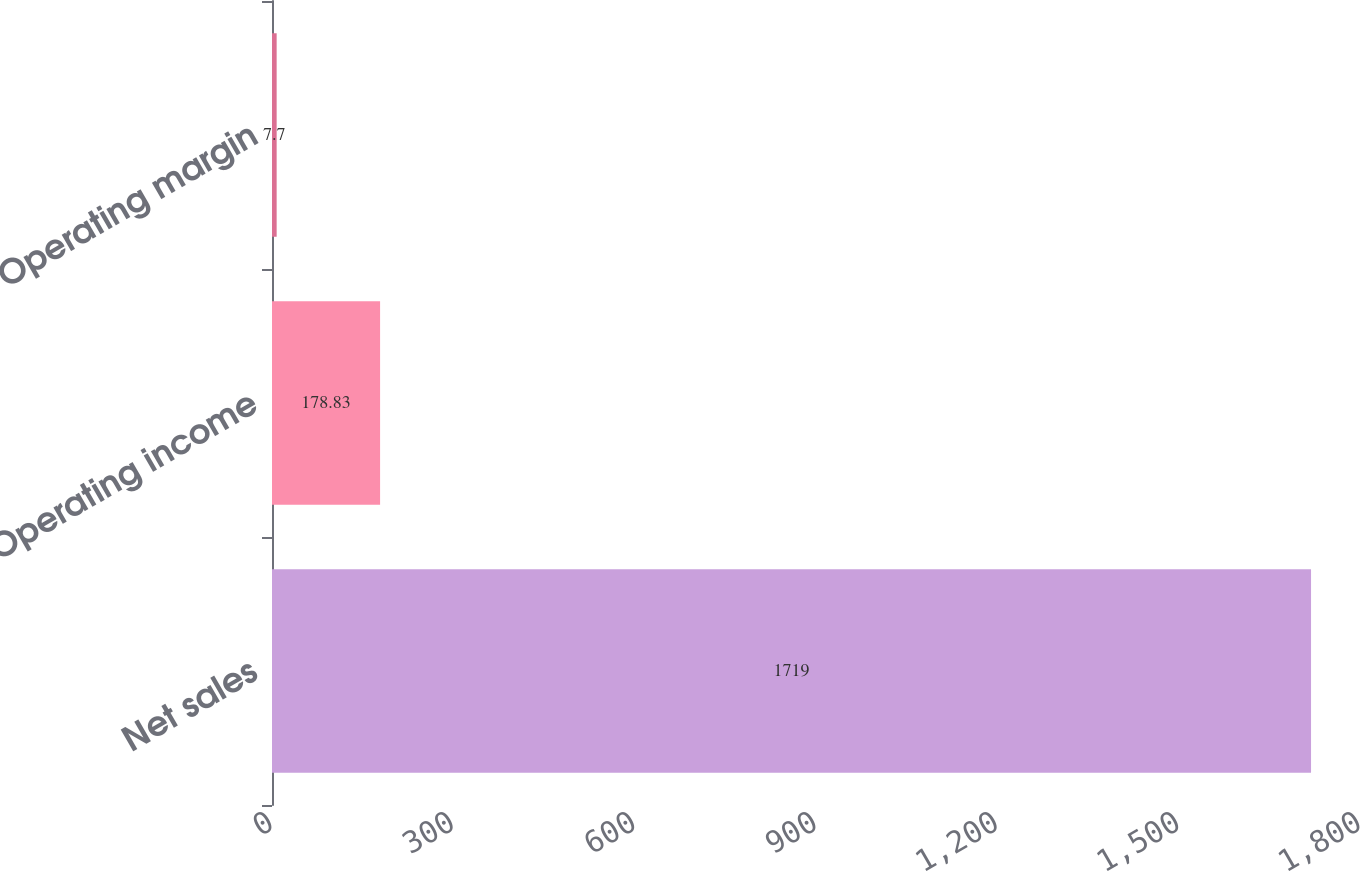Convert chart. <chart><loc_0><loc_0><loc_500><loc_500><bar_chart><fcel>Net sales<fcel>Operating income<fcel>Operating margin<nl><fcel>1719<fcel>178.83<fcel>7.7<nl></chart> 